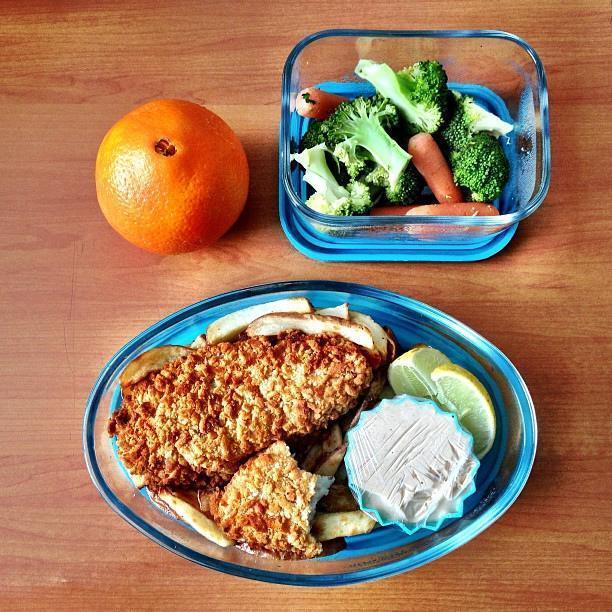How many bowls can be seen?
Give a very brief answer. 2. How many carrots are there?
Give a very brief answer. 1. How many legs of the elephant can you see?
Give a very brief answer. 0. 